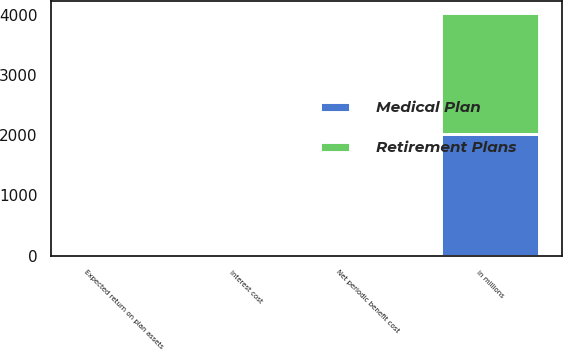Convert chart. <chart><loc_0><loc_0><loc_500><loc_500><stacked_bar_chart><ecel><fcel>in millions<fcel>Interest cost<fcel>Expected return on plan assets<fcel>Net periodic benefit cost<nl><fcel>Medical Plan<fcel>2014<fcel>21<fcel>24.6<fcel>3.2<nl><fcel>Retirement Plans<fcel>2014<fcel>1.8<fcel>0.3<fcel>5.1<nl></chart> 